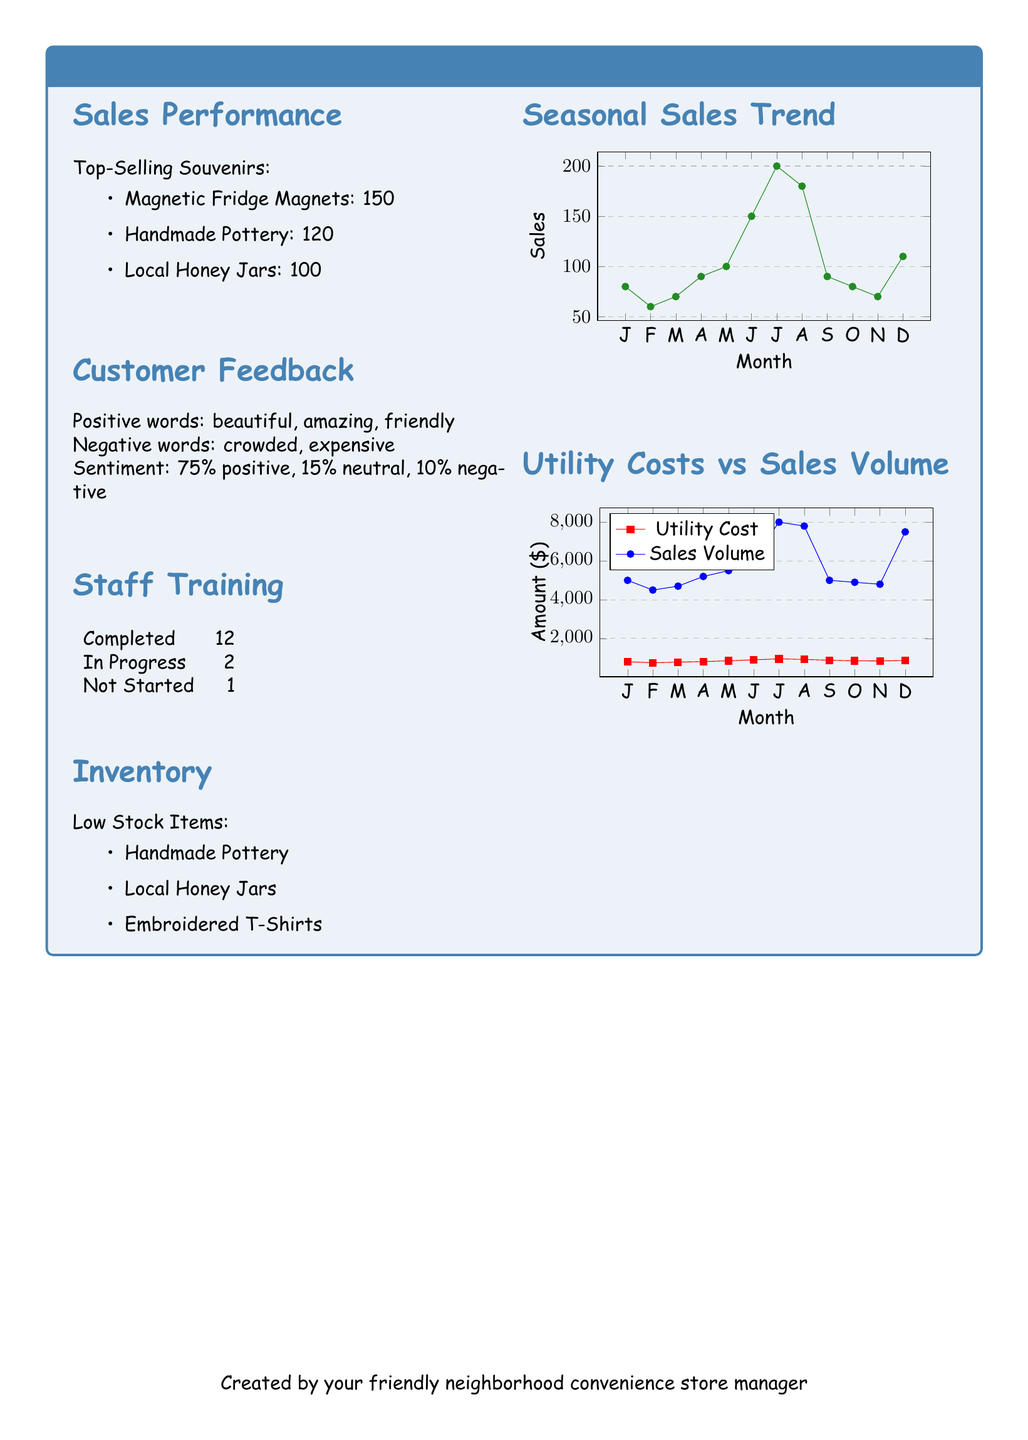What are the top-selling souvenirs? The document lists the top-selling souvenirs under the Sales Performance section, which includes the quantities sold for each.
Answer: Magnetic Fridge Magnets, Handmade Pottery, Local Honey Jars How many staff members have completed training? This information can be found in the Staff Training section of the document, which specifies the number of completed training sessions.
Answer: 12 What sentiment percentage is classified as positive? The sentiment analysis in the Customer Feedback section specifies the percentage of responses that are positive.
Answer: 75% Which item is marked as low stock? The Inventory section indicates which items are low stock currently.
Answer: Handmade Pottery What was the highest sales volume recorded? The highest sales volume is found in the Utility Costs vs Sales Volume section and represents the month with the most sales.
Answer: 8000 How many items are currently in progress for staff training? The Staff Training section provides a breakdown of the training status of staff members.
Answer: 2 Which month had the lowest utility cost? The Utility Costs vs Sales Volume section outlines the utility costs for each month, allowing for comparison.
Answer: February What was the sales amount in January? The document provides specific sales numbers for each month under the Utility Costs vs Sales Volume section.
Answer: 5000 